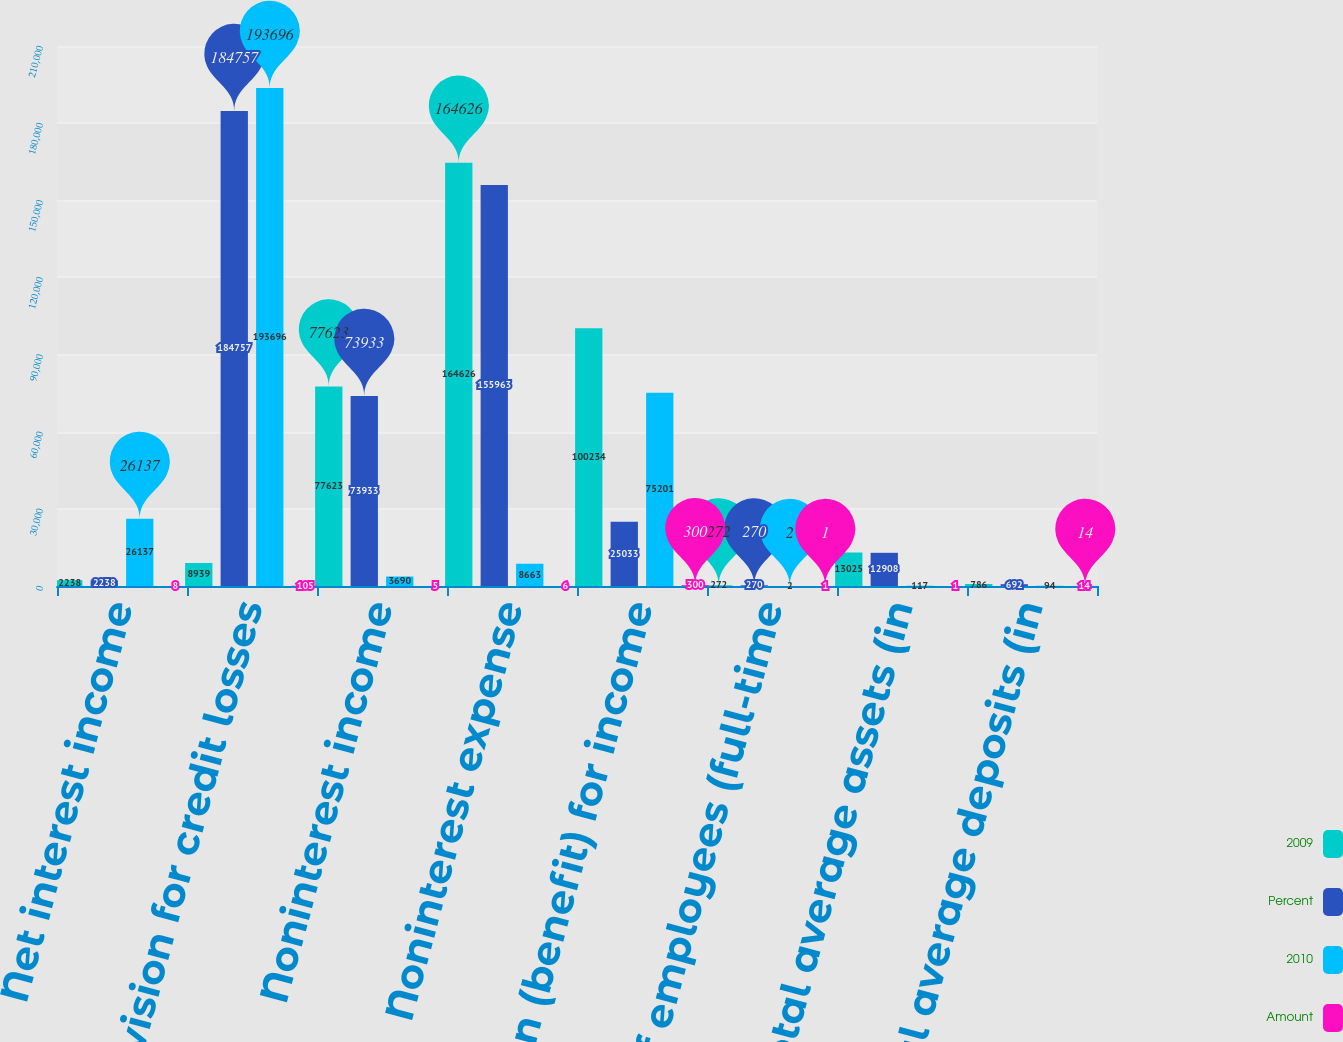<chart> <loc_0><loc_0><loc_500><loc_500><stacked_bar_chart><ecel><fcel>Net interest income<fcel>Provision for credit losses<fcel>Noninterest income<fcel>Noninterest expense<fcel>Provision (benefit) for income<fcel>Number of employees (full-time<fcel>Total average assets (in<fcel>Total average deposits (in<nl><fcel>2009<fcel>2238<fcel>8939<fcel>77623<fcel>164626<fcel>100234<fcel>272<fcel>13025<fcel>786<nl><fcel>Percent<fcel>2238<fcel>184757<fcel>73933<fcel>155963<fcel>25033<fcel>270<fcel>12908<fcel>692<nl><fcel>2010<fcel>26137<fcel>193696<fcel>3690<fcel>8663<fcel>75201<fcel>2<fcel>117<fcel>94<nl><fcel>Amount<fcel>8<fcel>105<fcel>5<fcel>6<fcel>300<fcel>1<fcel>1<fcel>14<nl></chart> 